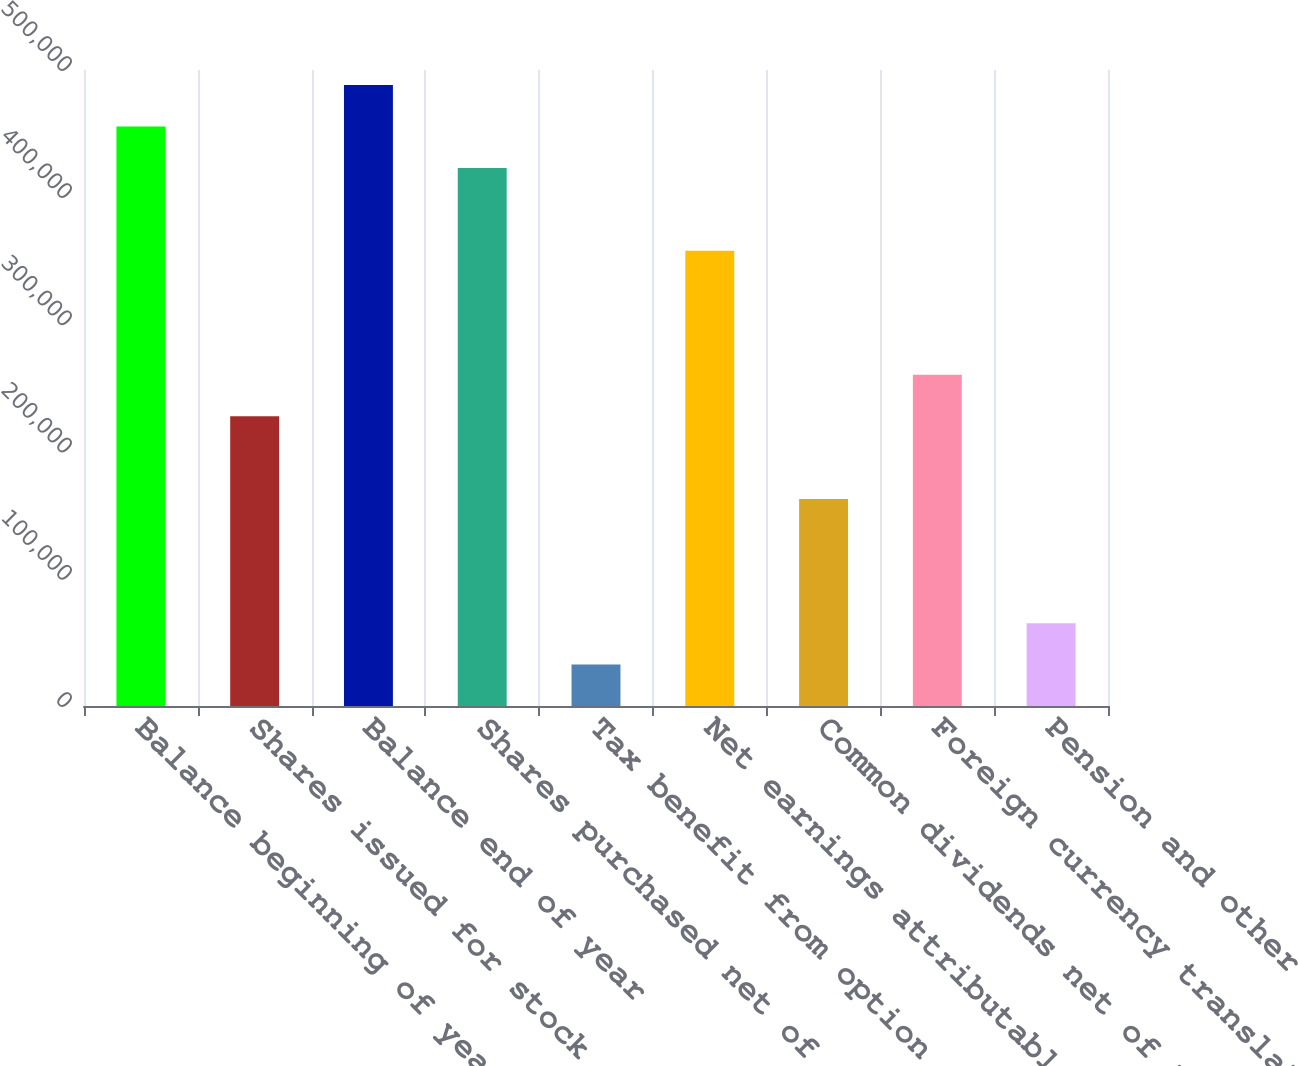Convert chart. <chart><loc_0><loc_0><loc_500><loc_500><bar_chart><fcel>Balance beginning of year<fcel>Shares issued for stock<fcel>Balance end of year<fcel>Shares purchased net of shares<fcel>Tax benefit from option<fcel>Net earnings attributable to<fcel>Common dividends net of tax<fcel>Foreign currency translation<fcel>Pension and other<nl><fcel>455590<fcel>227798<fcel>488132<fcel>423048<fcel>32547.2<fcel>357965<fcel>162714<fcel>260340<fcel>65089<nl></chart> 